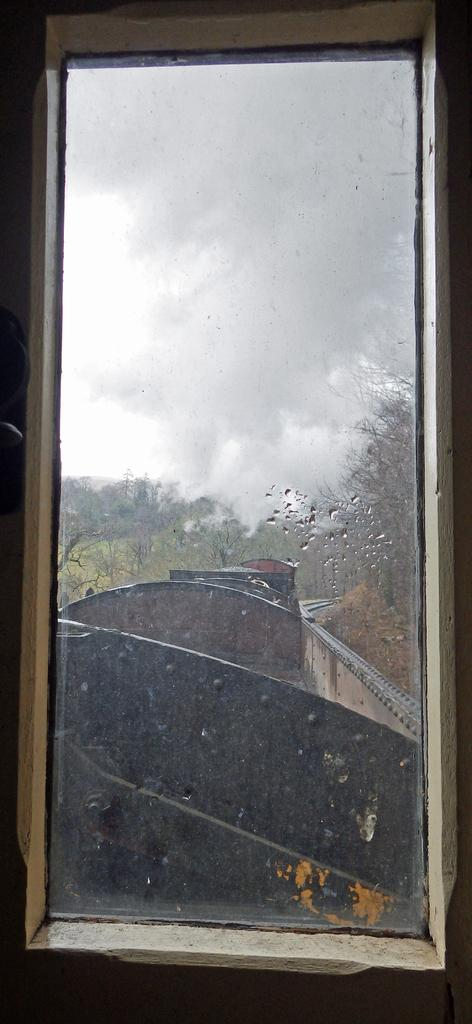What type of structure is present in the image? There is a glass window in the image. What can be seen through the window? A train, trees, and the sky are visible through the window. What design is present on the houses visible through the window? There are no houses visible through the window in the image. 